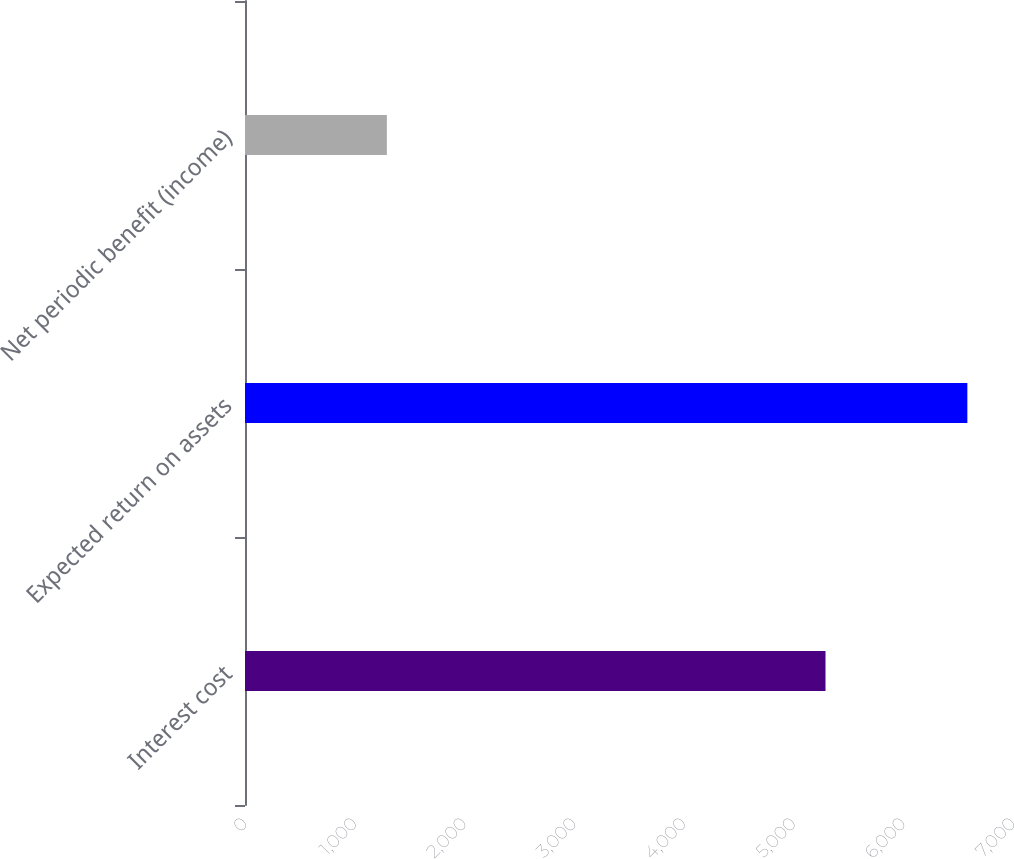Convert chart. <chart><loc_0><loc_0><loc_500><loc_500><bar_chart><fcel>Interest cost<fcel>Expected return on assets<fcel>Net periodic benefit (income)<nl><fcel>5291<fcel>6584<fcel>1293<nl></chart> 